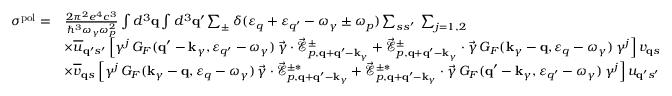Convert formula to latex. <formula><loc_0><loc_0><loc_500><loc_500>\begin{array} { r l } { \sigma ^ { p o l } = } & { \frac { 2 \pi ^ { 2 } e ^ { 4 } c ^ { 3 } } { \hbar { ^ } { 3 } \omega _ { \gamma } \omega _ { p } ^ { 2 } } \int d ^ { 3 } { q } \int d ^ { 3 } { q } ^ { \prime } \sum _ { \pm } \delta ( \varepsilon _ { q } + \varepsilon _ { q ^ { \prime } } - \omega _ { \gamma } \pm \omega _ { p } ) \sum _ { s s ^ { \prime } } \, \sum _ { j = 1 , 2 } } \\ & { \times \overline { u } _ { { q } ^ { \prime } s ^ { \prime } } \, \left [ \gamma ^ { j } \, G _ { F } ( { q } ^ { \prime } - { k } _ { \gamma } , \varepsilon _ { q ^ { \prime } } - \omega _ { \gamma } ) \, \vec { \gamma } \cdot \vec { \mathcal { E } } _ { p , { q } + { q } ^ { \prime } - { k } _ { \gamma } } ^ { \pm } + \vec { \mathcal { E } } _ { p , { q } + { q } ^ { \prime } - { k } _ { \gamma } } ^ { \pm } \cdot \vec { \gamma } \, G _ { F } ( { k } _ { \gamma } - { q } , \varepsilon _ { q } - \omega _ { \gamma } ) \, \gamma ^ { j } \right ] \, v _ { { q } s } } \\ & { \times \overline { v } _ { { q } s } \, \left [ \gamma ^ { j } \, G _ { F } ( { k } _ { \gamma } - { q } , \varepsilon _ { q } - \omega _ { \gamma } ) \, \vec { \gamma } \cdot \vec { \mathcal { E } } _ { p , { q } + { q } ^ { \prime } - { k } _ { \gamma } } ^ { \pm * } + \vec { \mathcal { E } } _ { p , { q } + { q } ^ { \prime } - { k } _ { \gamma } } ^ { \pm * } \cdot \vec { \gamma } \, G _ { F } ( { q } ^ { \prime } - { k } _ { \gamma } , \varepsilon _ { q ^ { \prime } } - \omega _ { \gamma } ) \, \gamma ^ { j } \right ] \, u _ { { q } ^ { \prime } s ^ { \prime } } } \end{array}</formula> 